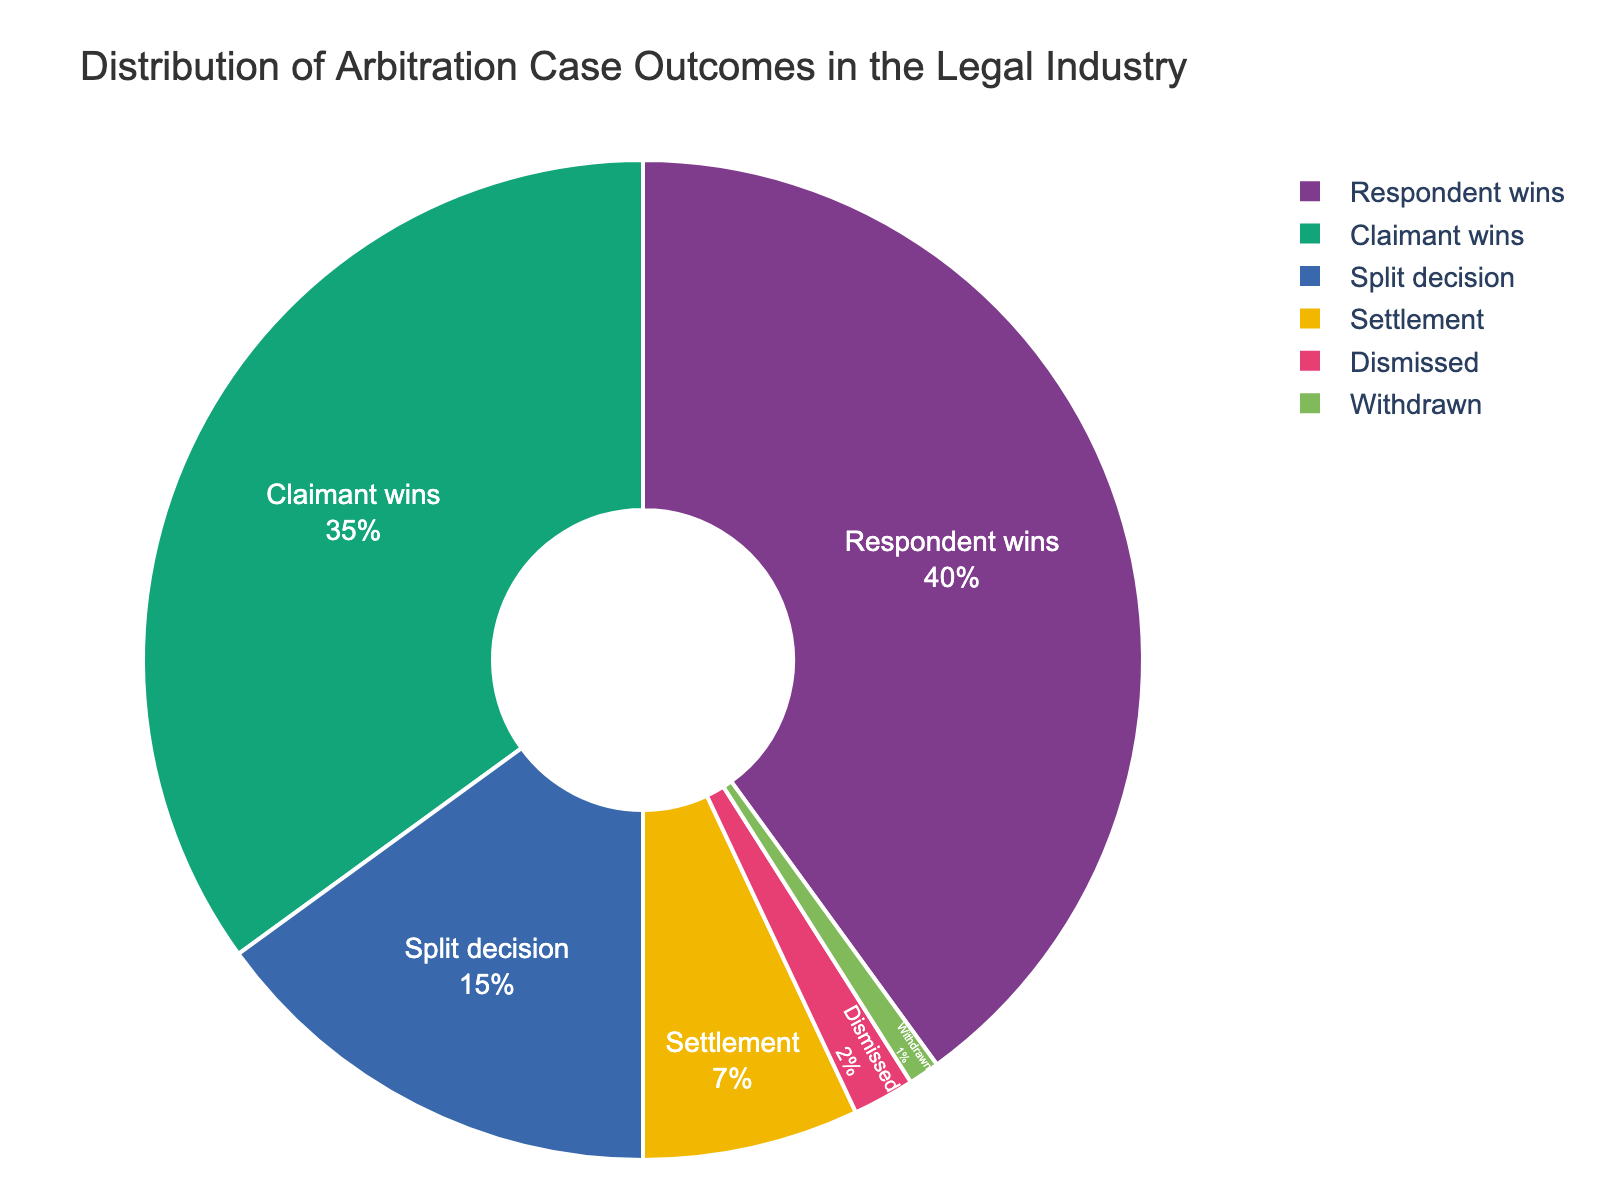Which outcome category has the highest percentage? By looking at the pie chart, we can see which category takes up the largest segment. The largest segment is labeled "Respondent wins" at 40%.
Answer: Respondent wins What is the combined percentage of cases where the outcome is either a "Split decision" or "Settlement"? To find the combined percentage, we add the percentages for "Split decision" and "Settlement". This gives us 15% + 7% = 22%.
Answer: 22% How does the percentage of "Claimant wins" compare to "Respondent wins"? We compare the percentage values: "Claimant wins" is 35% and "Respondent wins" is 40%. Therefore, "Respondent wins" has a higher percentage by 5%.
Answer: Respondent wins is higher by 5% What is the smallest outcome category shown in the pie chart? We identify the smallest segment by looking for the category with the lowest percentage. "Withdrawn" is the smallest at 1%.
Answer: Withdrawn If you combine "Dismissed" and "Withdrawn" cases, do they account for more or less than 5% of the total? Adding the percentages of "Dismissed" (2%) and "Withdrawn" (1%) gives us 3%. Since 3% is less than 5%, they account for less than 5% of the total.
Answer: Less than 5% Which category has a higher percentage, "Split decision" or "Settlement"? By comparing the percentages of "Split decision" (15%) and "Settlement" (7%), we see that "Split decision" has a higher percentage.
Answer: Split decision What proportion of cases result in either a win for the claimant or the respondent? Adding the percentages for "Claimant wins" (35%) and "Respondent wins" (40%) gives us the combined proportion: 35% + 40% = 75%.
Answer: 75% By looking at the color, which categories seem to have more emphasis? Larger segments usually use more vivid colors to draw attention. The largest portions, "Claimant wins" and "Respondent wins," have bold colors and take up most of the pie.
Answer: Claimant wins, Respondent wins 